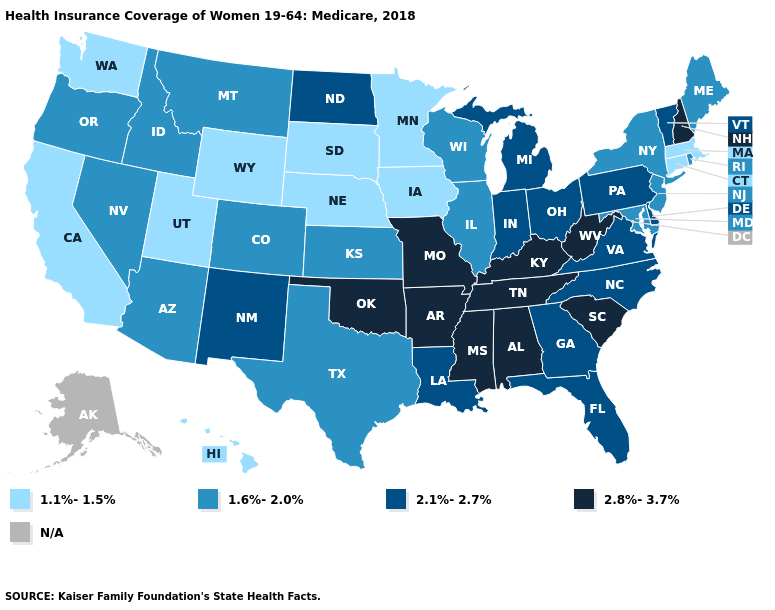Does Mississippi have the lowest value in the USA?
Quick response, please. No. Name the states that have a value in the range N/A?
Answer briefly. Alaska. Which states hav the highest value in the MidWest?
Short answer required. Missouri. What is the lowest value in the South?
Write a very short answer. 1.6%-2.0%. How many symbols are there in the legend?
Be succinct. 5. What is the value of Nebraska?
Give a very brief answer. 1.1%-1.5%. What is the lowest value in states that border Mississippi?
Be succinct. 2.1%-2.7%. What is the lowest value in the West?
Be succinct. 1.1%-1.5%. Does Texas have the highest value in the South?
Be succinct. No. What is the highest value in the Northeast ?
Answer briefly. 2.8%-3.7%. What is the value of Pennsylvania?
Concise answer only. 2.1%-2.7%. What is the value of Kansas?
Write a very short answer. 1.6%-2.0%. 